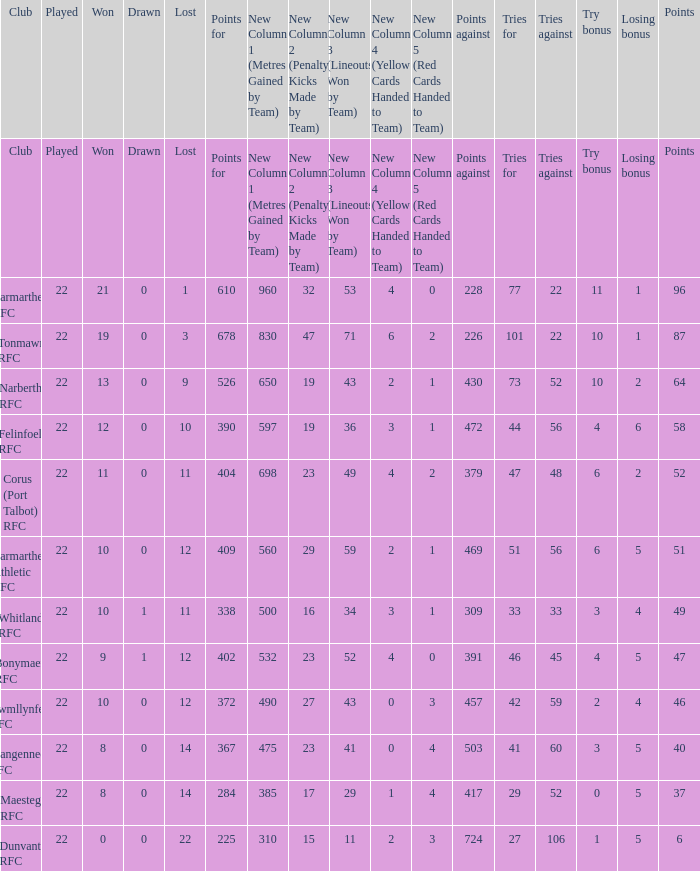Name the points against for 51 points 469.0. 